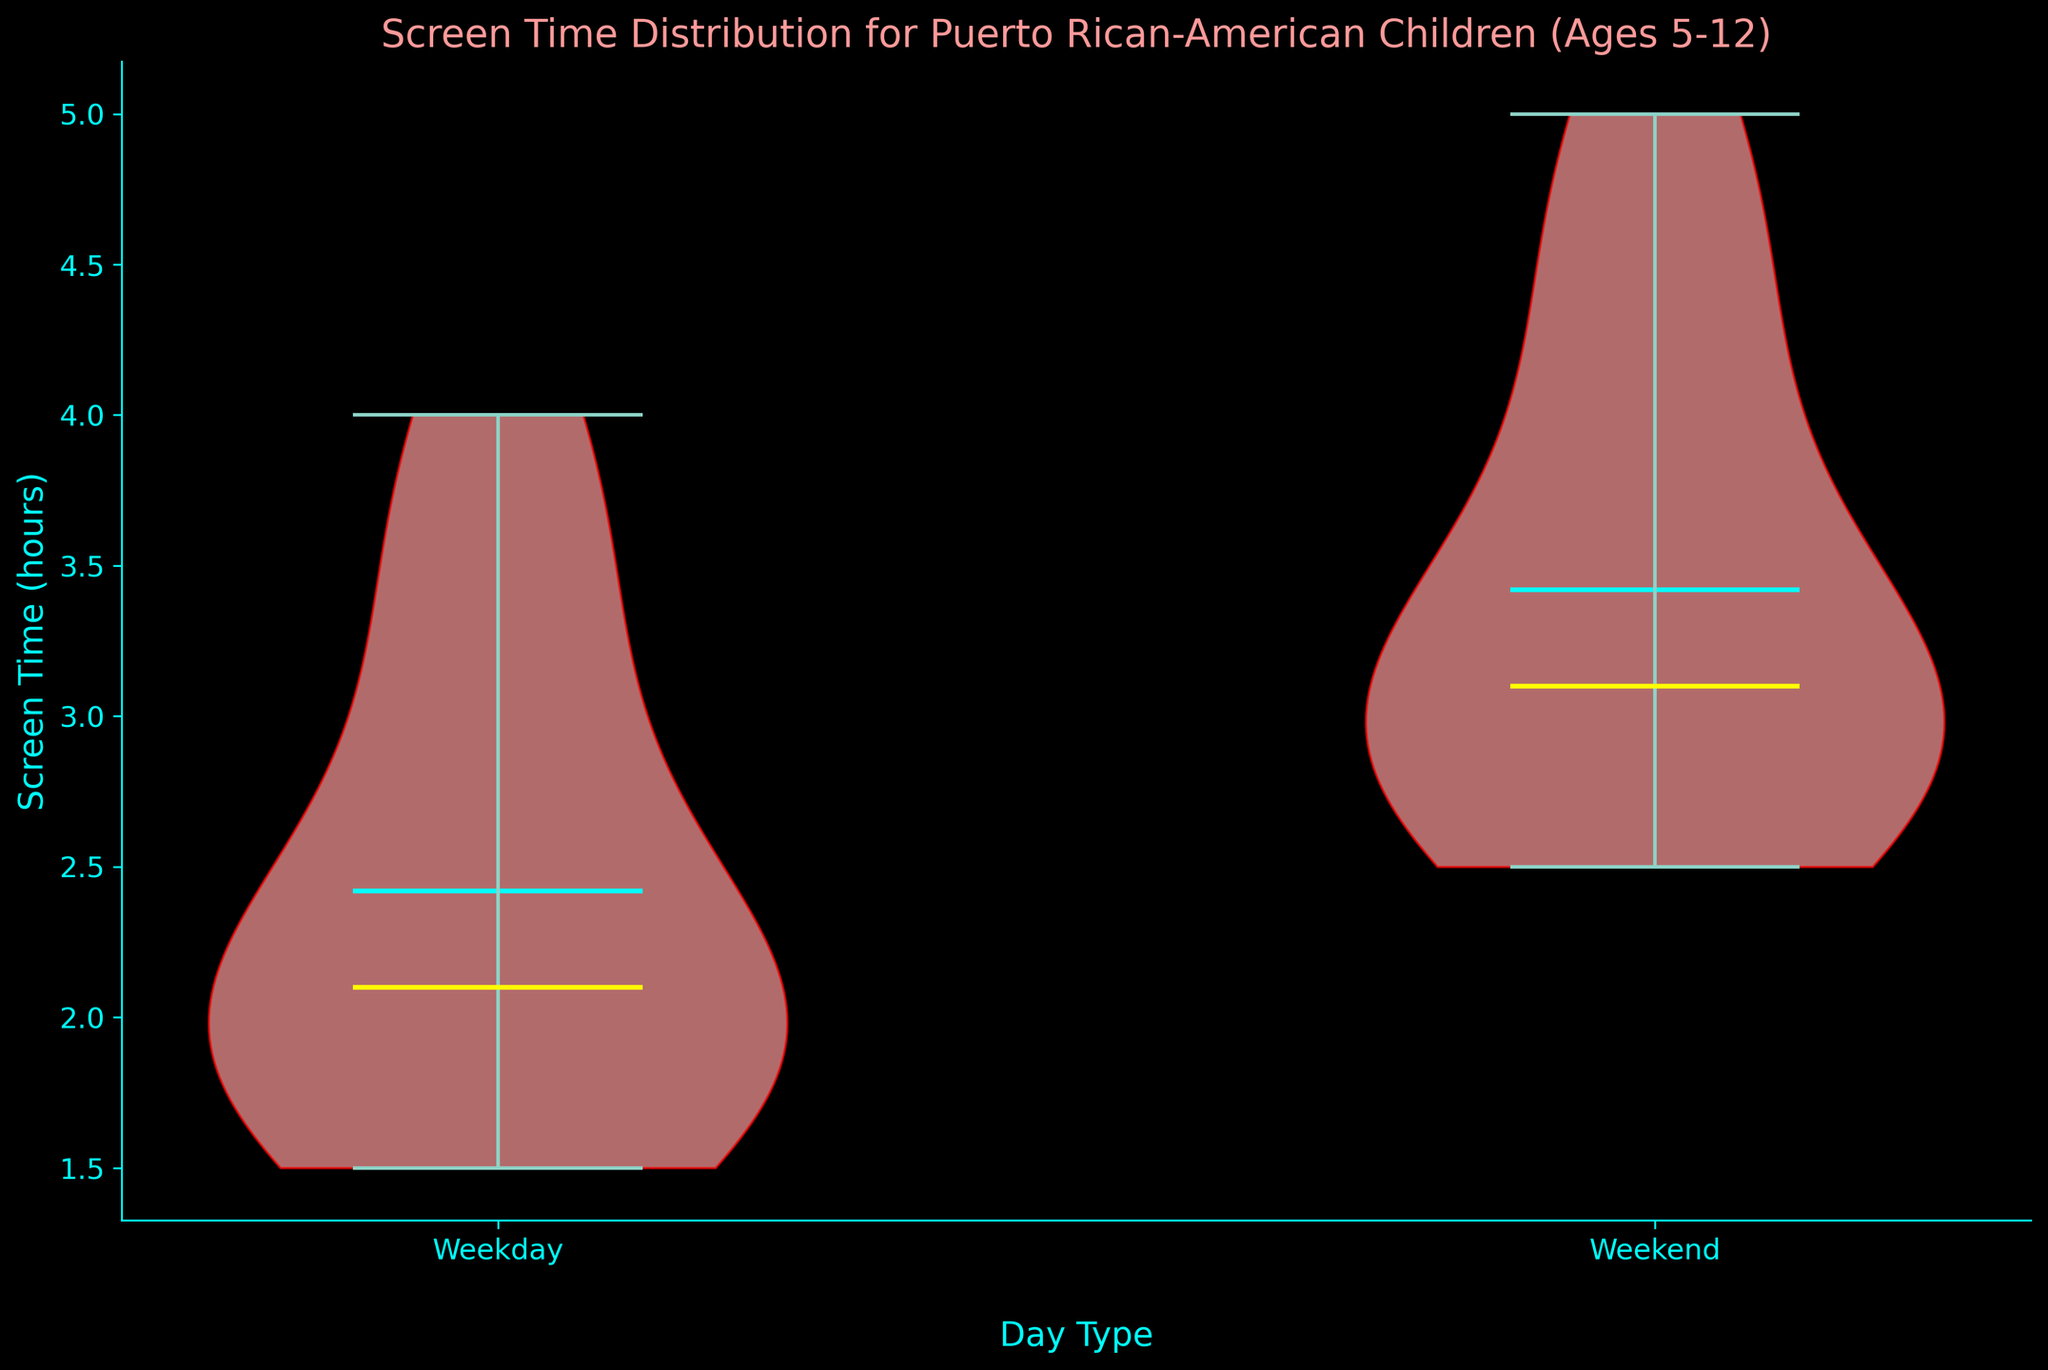Which day type is represented by the first violin plot on the x-axis? The first violin plot on the x-axis is labeled as "Weekday" according to the figure's xticks.
Answer: Weekday What is the median screen time for children on weekends? The median screen time for weekends is indicated by the yellow line within the second violin plot. Based on the visual representation, the median screen time for weekends is just around 3.5 hours.
Answer: Approximately 3.5 hours How do the means of screen time compare between weekdays and weekends? The means are marked by the cyan lines in each violin plot. The weekday mean lies between 2 and 2.5 hours, and the weekend mean is higher, closer to 3.5 hours. Therefore, children tend to have more screen time on weekends compared to weekdays.
Answer: Weekend mean is higher What are the extreme values of screen time on weekdays? The extrema (min and max values) are marked by the limits of the thin vertical lines extending from the body of the violin plots. For weekdays, the minimum appears around 1.5 hours and the maximum around 4 hours.
Answer: 1.5 hours to 4 hours Which day type shows more variability in children's screen time? Variability can be interpreted from the width and length of the violin plots. The weekend plot is wider and taller than the weekday plot, indicating greater variability.
Answer: Weekend What is the title of this figure? The title of the figure is displayed at the top and reads "Screen Time Distribution for Puerto Rican-American Children (Ages 5-12)."
Answer: Screen Time Distribution for Puerto Rican-American Children (Ages 5-12) What color is used to fill the violin plots? The violin plots are filled with a light red color, as observed from their visual appearance.
Answer: Light red Compare the screen time distribution's central tendencies for weekdays and weekends. The central tendency can be read from the means and medians. The mean screen time for weekdays (cyan line) is closer to 2.5 hours, while the weekend mean is around 3.5 hours. The weekday median is also lower than the weekend median.
Answer: Weekend’s central tendency is higher What is the approximate mean screen time on weekdays? The mean screen time on weekdays is indicated by the cyan line within the first violin plot, and it is slightly above 2 hours.
Answer: Approximately 2.5 hours How does the median screen time on weekends compare to the mean screen time on weekdays? The median screen time on weekends (yellow line in the second plot) is about 3.5 hours, which is higher than the mean screen time on weekdays (cyan line in the first plot) close to 2.5 hours.
Answer: Weekend median is higher 